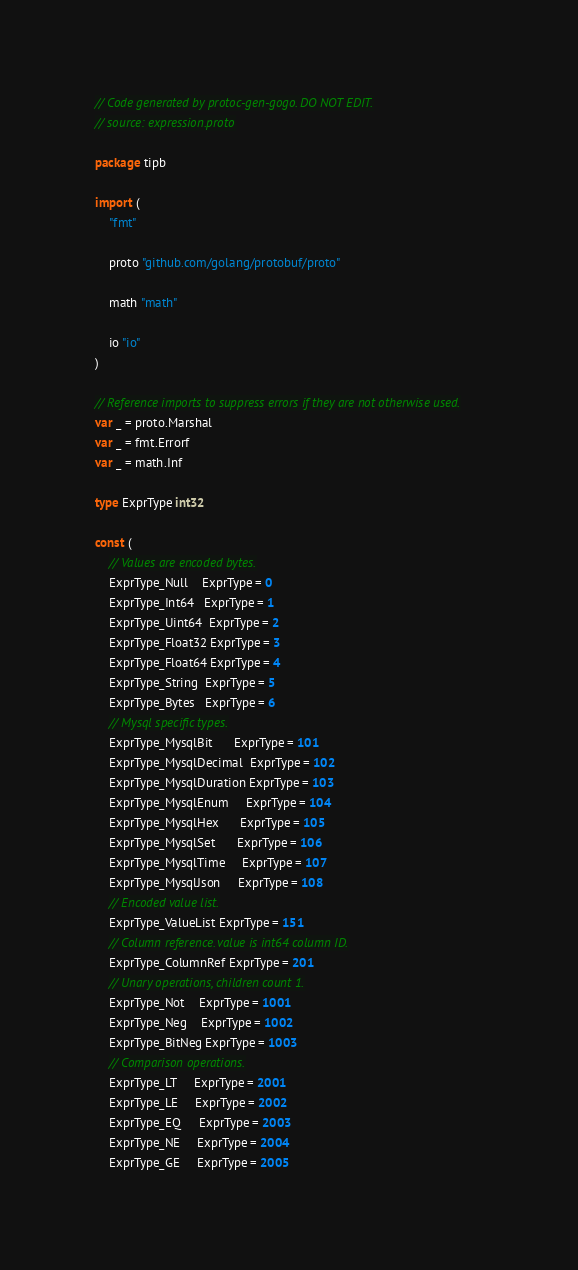<code> <loc_0><loc_0><loc_500><loc_500><_Go_>// Code generated by protoc-gen-gogo. DO NOT EDIT.
// source: expression.proto

package tipb

import (
	"fmt"

	proto "github.com/golang/protobuf/proto"

	math "math"

	io "io"
)

// Reference imports to suppress errors if they are not otherwise used.
var _ = proto.Marshal
var _ = fmt.Errorf
var _ = math.Inf

type ExprType int32

const (
	// Values are encoded bytes.
	ExprType_Null    ExprType = 0
	ExprType_Int64   ExprType = 1
	ExprType_Uint64  ExprType = 2
	ExprType_Float32 ExprType = 3
	ExprType_Float64 ExprType = 4
	ExprType_String  ExprType = 5
	ExprType_Bytes   ExprType = 6
	// Mysql specific types.
	ExprType_MysqlBit      ExprType = 101
	ExprType_MysqlDecimal  ExprType = 102
	ExprType_MysqlDuration ExprType = 103
	ExprType_MysqlEnum     ExprType = 104
	ExprType_MysqlHex      ExprType = 105
	ExprType_MysqlSet      ExprType = 106
	ExprType_MysqlTime     ExprType = 107
	ExprType_MysqlJson     ExprType = 108
	// Encoded value list.
	ExprType_ValueList ExprType = 151
	// Column reference. value is int64 column ID.
	ExprType_ColumnRef ExprType = 201
	// Unary operations, children count 1.
	ExprType_Not    ExprType = 1001
	ExprType_Neg    ExprType = 1002
	ExprType_BitNeg ExprType = 1003
	// Comparison operations.
	ExprType_LT     ExprType = 2001
	ExprType_LE     ExprType = 2002
	ExprType_EQ     ExprType = 2003
	ExprType_NE     ExprType = 2004
	ExprType_GE     ExprType = 2005</code> 